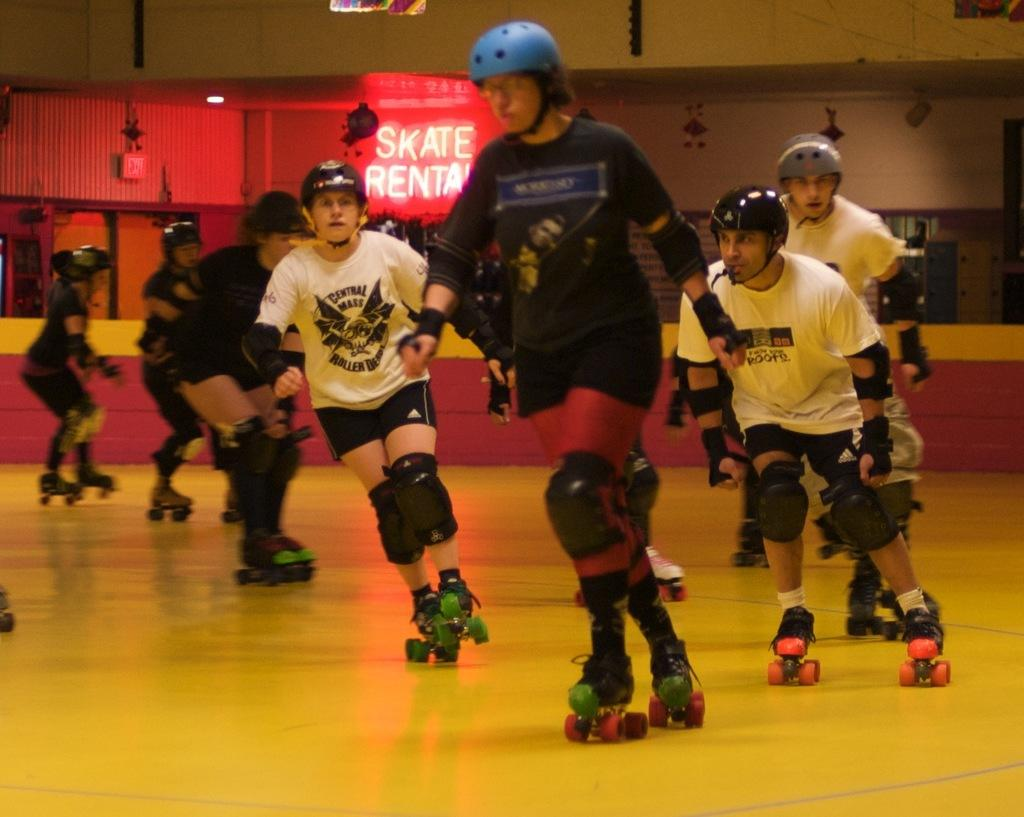What type of clothing are some people wearing on their upper bodies in the image? Some people are wearing t-shirts in the image. What type of clothing are some people wearing on their lower bodies in the image? Some people are wearing shorts in the image. What type of protective gear are some people wearing on their heads in the image? Some people are wearing helmets on their heads in the image. What activity are the people engaged in? The people are skating on a floor in the image. What color is the floor they are skating on? The floor is in yellow color. What can be seen in the background of the image? There is a wall visible in the background. How many ants can be seen crawling on the wall in the image? There are no ants visible on the wall in the image. What type of family is depicted in the image? There is no family depicted in the image; it features people skating on a floor. 